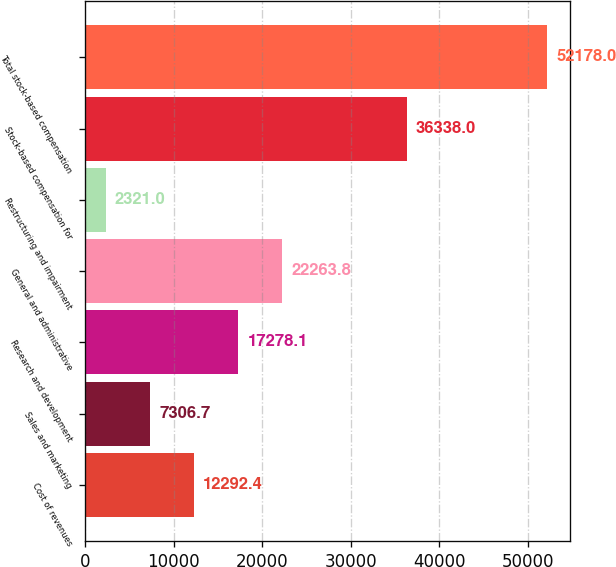<chart> <loc_0><loc_0><loc_500><loc_500><bar_chart><fcel>Cost of revenues<fcel>Sales and marketing<fcel>Research and development<fcel>General and administrative<fcel>Restructuring and impairment<fcel>Stock-based compensation for<fcel>Total stock-based compensation<nl><fcel>12292.4<fcel>7306.7<fcel>17278.1<fcel>22263.8<fcel>2321<fcel>36338<fcel>52178<nl></chart> 